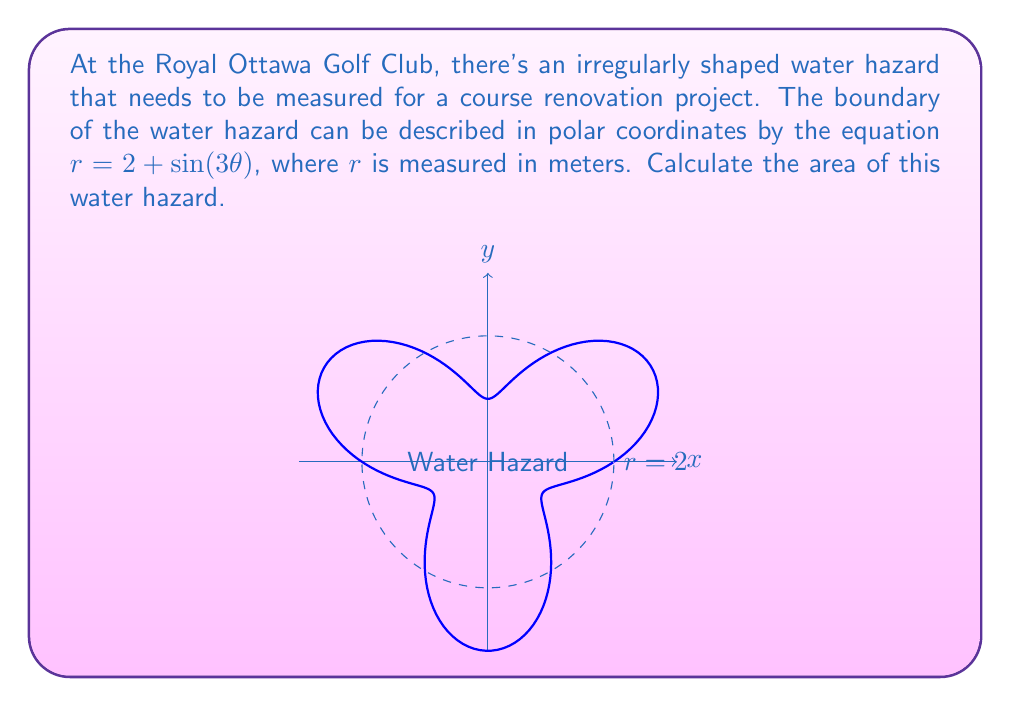Teach me how to tackle this problem. To find the area of this irregularly shaped water hazard, we need to use polar integration. The formula for the area of a region in polar coordinates is:

$$A = \frac{1}{2} \int_{0}^{2\pi} r^2(\theta) \, d\theta$$

Given: $r = 2 + \sin(3\theta)$

Let's follow these steps:

1) Square the radius function:
   $$r^2 = (2 + \sin(3\theta))^2 = 4 + 4\sin(3\theta) + \sin^2(3\theta)$$

2) Set up the integral:
   $$A = \frac{1}{2} \int_{0}^{2\pi} (4 + 4\sin(3\theta) + \sin^2(3\theta)) \, d\theta$$

3) Integrate each term:
   - $\int_{0}^{2\pi} 4 \, d\theta = 4\theta \big|_{0}^{2\pi} = 8\pi$
   - $\int_{0}^{2\pi} 4\sin(3\theta) \, d\theta = -\frac{4}{3}\cos(3\theta) \big|_{0}^{2\pi} = 0$
   - $\int_{0}^{2\pi} \sin^2(3\theta) \, d\theta = \int_{0}^{2\pi} \frac{1-\cos(6\theta)}{2} \, d\theta = \frac{\theta}{2} - \frac{\sin(6\theta)}{12} \big|_{0}^{2\pi} = \pi$

4) Sum up the results:
   $$A = \frac{1}{2} (8\pi + 0 + \pi) = \frac{9\pi}{2}$$

Therefore, the area of the water hazard is $\frac{9\pi}{2}$ square meters.
Answer: $\frac{9\pi}{2}$ square meters 